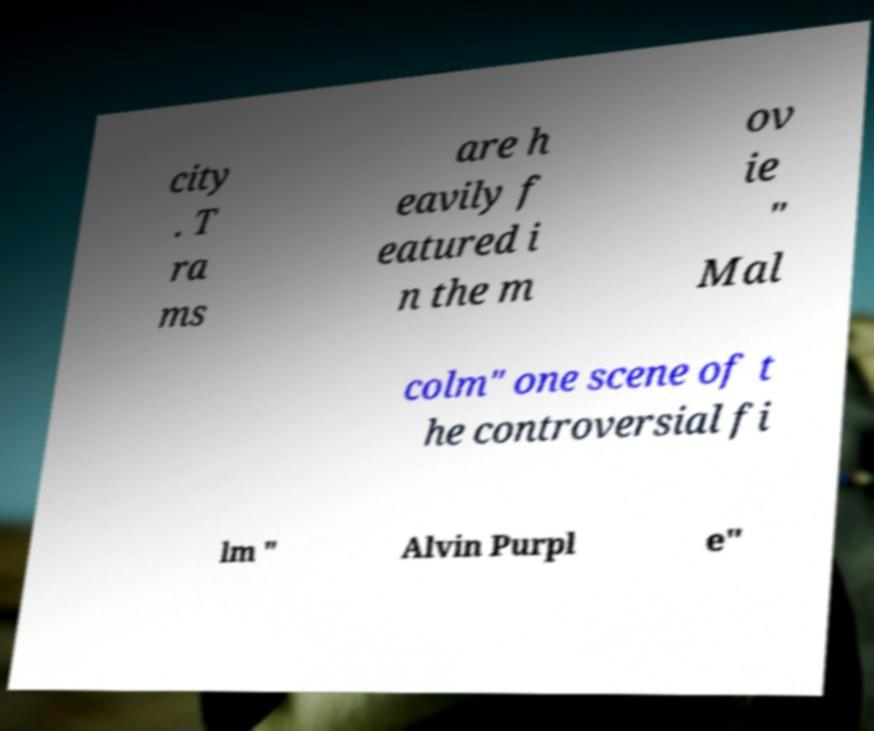For documentation purposes, I need the text within this image transcribed. Could you provide that? city . T ra ms are h eavily f eatured i n the m ov ie " Mal colm" one scene of t he controversial fi lm " Alvin Purpl e" 